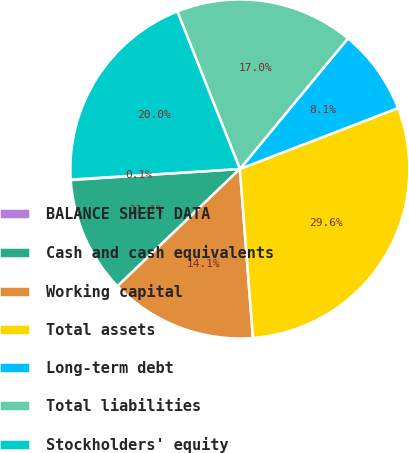Convert chart. <chart><loc_0><loc_0><loc_500><loc_500><pie_chart><fcel>BALANCE SHEET DATA<fcel>Cash and cash equivalents<fcel>Working capital<fcel>Total assets<fcel>Long-term debt<fcel>Total liabilities<fcel>Stockholders' equity<nl><fcel>0.05%<fcel>11.11%<fcel>14.07%<fcel>29.62%<fcel>8.15%<fcel>17.02%<fcel>19.98%<nl></chart> 